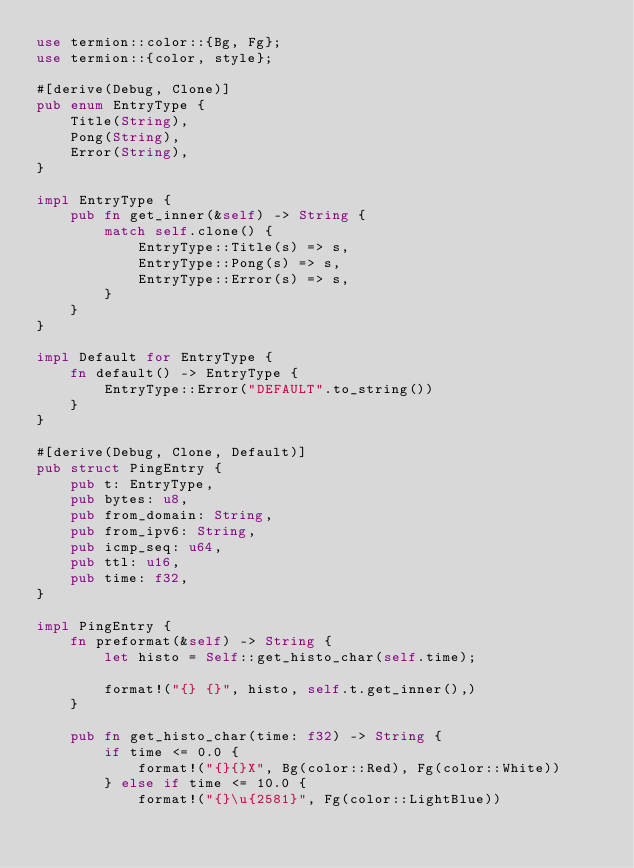<code> <loc_0><loc_0><loc_500><loc_500><_Rust_>use termion::color::{Bg, Fg};
use termion::{color, style};

#[derive(Debug, Clone)]
pub enum EntryType {
    Title(String),
    Pong(String),
    Error(String),
}

impl EntryType {
    pub fn get_inner(&self) -> String {
        match self.clone() {
            EntryType::Title(s) => s,
            EntryType::Pong(s) => s,
            EntryType::Error(s) => s,
        }
    }
}

impl Default for EntryType {
    fn default() -> EntryType {
        EntryType::Error("DEFAULT".to_string())
    }
}

#[derive(Debug, Clone, Default)]
pub struct PingEntry {
    pub t: EntryType,
    pub bytes: u8,
    pub from_domain: String,
    pub from_ipv6: String,
    pub icmp_seq: u64,
    pub ttl: u16,
    pub time: f32,
}

impl PingEntry {
    fn preformat(&self) -> String {
        let histo = Self::get_histo_char(self.time);

        format!("{} {}", histo, self.t.get_inner(),)
    }

    pub fn get_histo_char(time: f32) -> String {
        if time <= 0.0 {
            format!("{}{}X", Bg(color::Red), Fg(color::White))
        } else if time <= 10.0 {
            format!("{}\u{2581}", Fg(color::LightBlue))</code> 